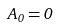<formula> <loc_0><loc_0><loc_500><loc_500>A _ { 0 } = 0</formula> 